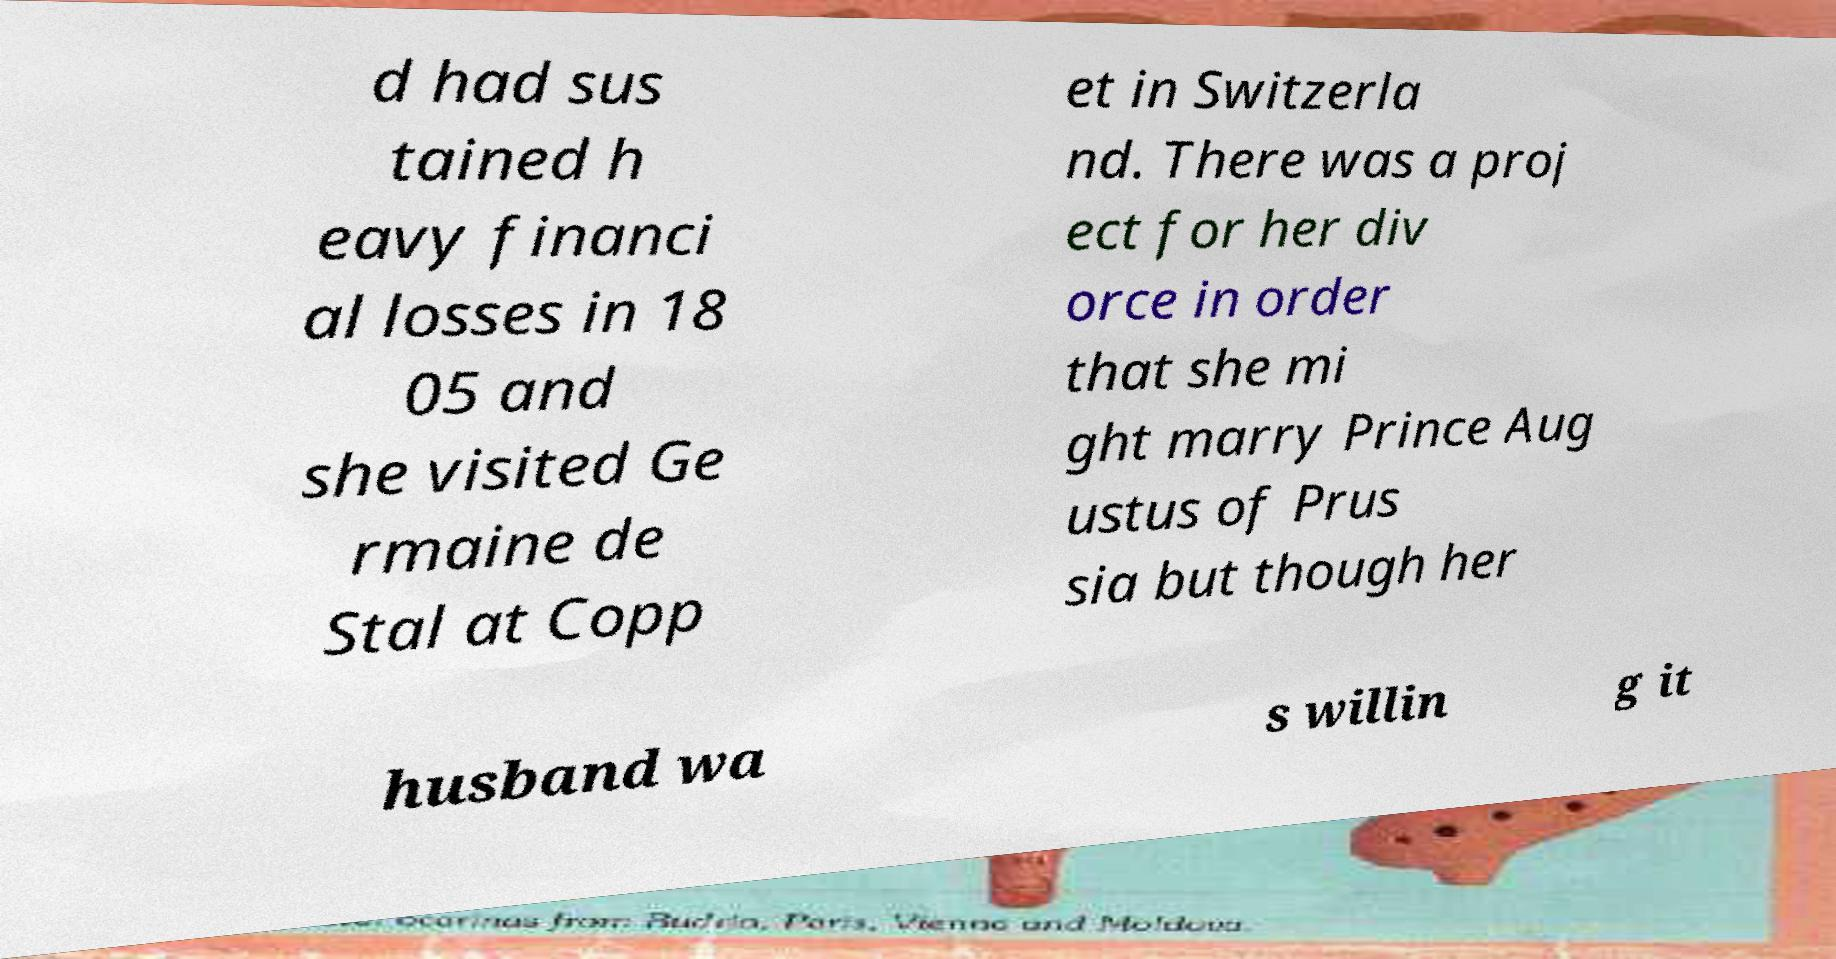I need the written content from this picture converted into text. Can you do that? d had sus tained h eavy financi al losses in 18 05 and she visited Ge rmaine de Stal at Copp et in Switzerla nd. There was a proj ect for her div orce in order that she mi ght marry Prince Aug ustus of Prus sia but though her husband wa s willin g it 